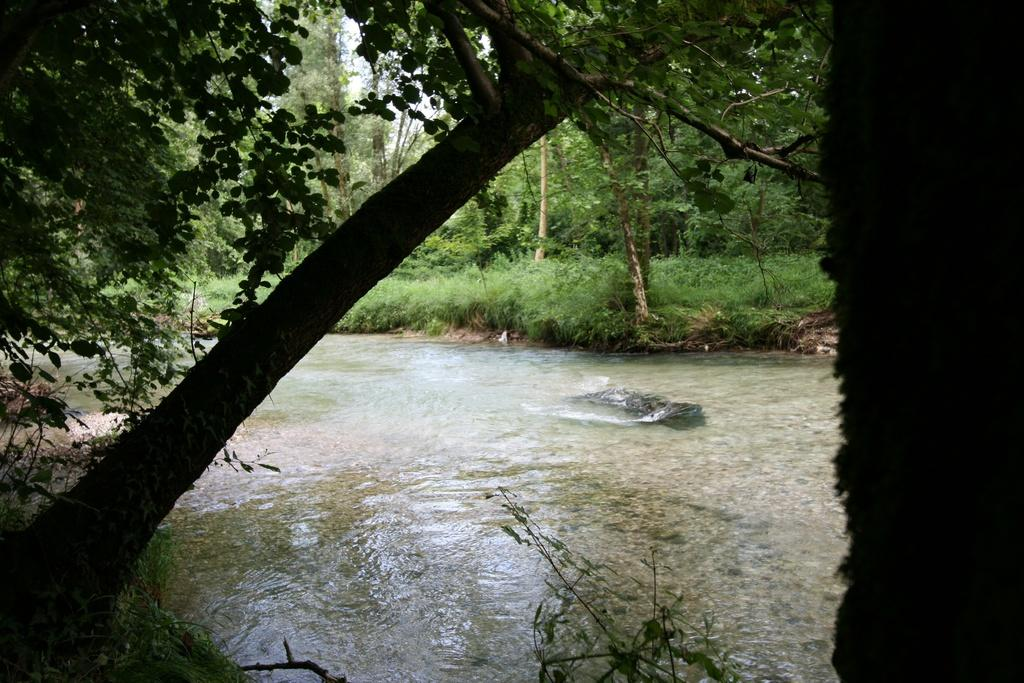What type of vegetation is present in the image? There are trees in front of the image and in the background. What natural element is visible in the image? Water is visible in the image. What type of surface is present in the background of the image? There is grass on the surface in the background of the image. What can be seen at the top of the image? The sky is visible at the top of the image. What type of toy is being used to knit yarn in the image? There is no toy or yarn present in the image. How many light bulbs can be seen illuminating the trees in the image? There are no light bulbs present in the image; it features trees, water, grass, and the sky. 